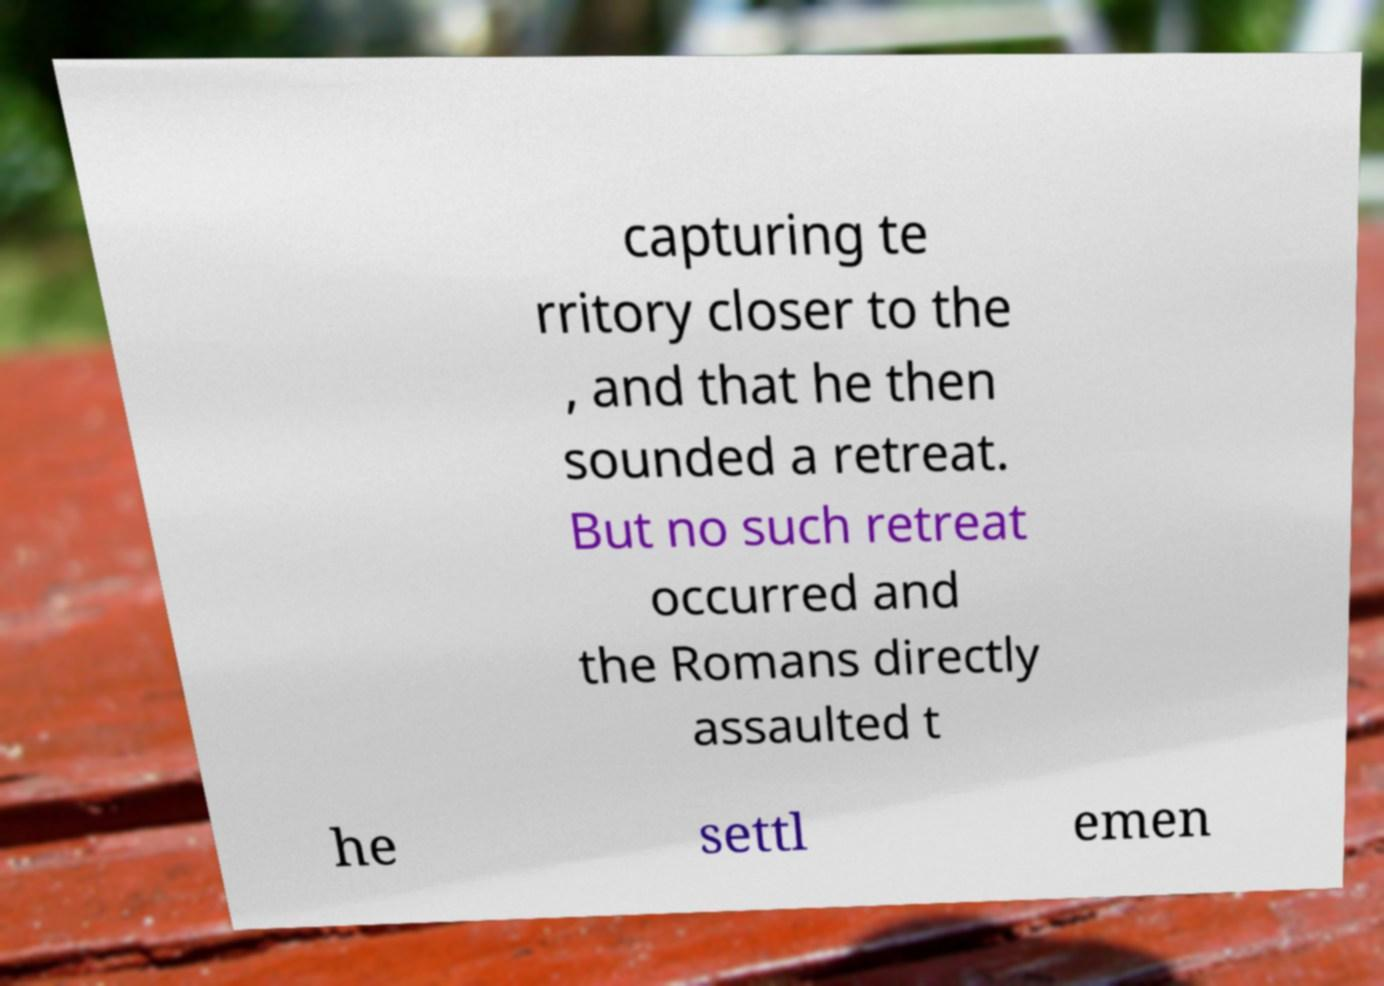What messages or text are displayed in this image? I need them in a readable, typed format. capturing te rritory closer to the , and that he then sounded a retreat. But no such retreat occurred and the Romans directly assaulted t he settl emen 